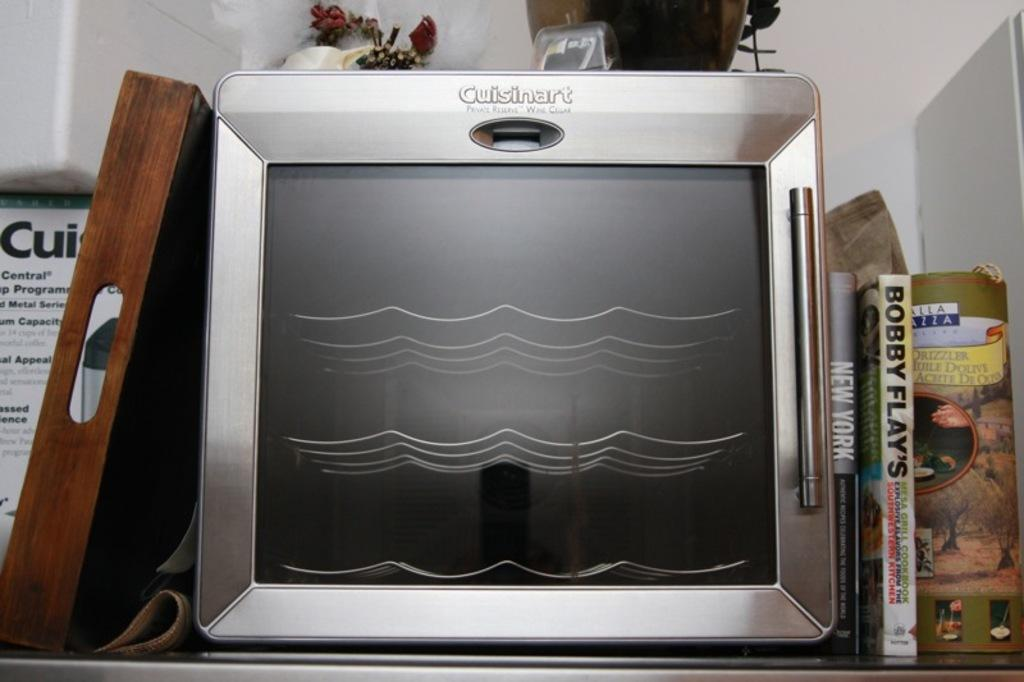<image>
Describe the image concisely. A Cuisinart microwave oven is on a counter. 